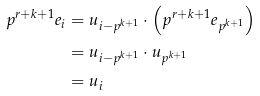<formula> <loc_0><loc_0><loc_500><loc_500>p ^ { r + k + 1 } e _ { i } & = u _ { i - p ^ { k + 1 } } \cdot \left ( p ^ { r + k + 1 } e _ { p ^ { k + 1 } } \right ) \\ & = u _ { i - p ^ { k + 1 } } \cdot u _ { p ^ { k + 1 } } \\ & = u _ { i }</formula> 